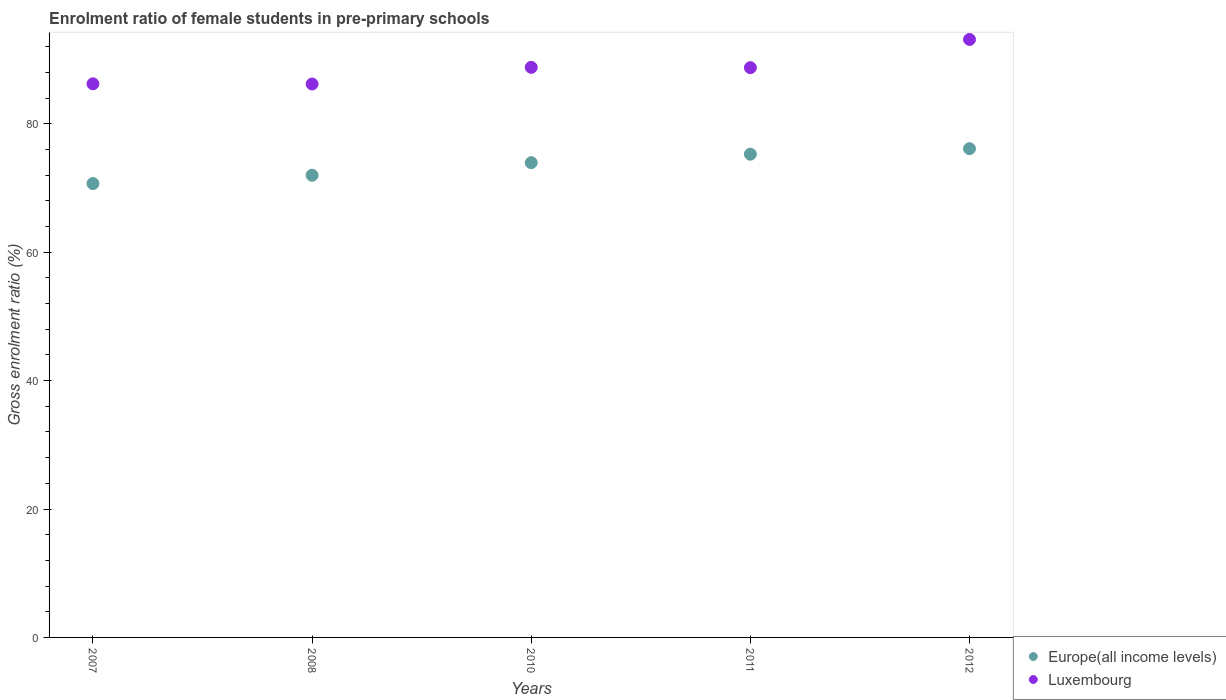How many different coloured dotlines are there?
Offer a very short reply. 2. What is the enrolment ratio of female students in pre-primary schools in Luxembourg in 2010?
Make the answer very short. 88.79. Across all years, what is the maximum enrolment ratio of female students in pre-primary schools in Europe(all income levels)?
Ensure brevity in your answer.  76.12. Across all years, what is the minimum enrolment ratio of female students in pre-primary schools in Europe(all income levels)?
Offer a terse response. 70.69. What is the total enrolment ratio of female students in pre-primary schools in Europe(all income levels) in the graph?
Offer a very short reply. 368. What is the difference between the enrolment ratio of female students in pre-primary schools in Europe(all income levels) in 2008 and that in 2012?
Your response must be concise. -4.14. What is the difference between the enrolment ratio of female students in pre-primary schools in Luxembourg in 2011 and the enrolment ratio of female students in pre-primary schools in Europe(all income levels) in 2007?
Offer a terse response. 18.05. What is the average enrolment ratio of female students in pre-primary schools in Europe(all income levels) per year?
Your answer should be very brief. 73.6. In the year 2012, what is the difference between the enrolment ratio of female students in pre-primary schools in Europe(all income levels) and enrolment ratio of female students in pre-primary schools in Luxembourg?
Your answer should be very brief. -17.01. What is the ratio of the enrolment ratio of female students in pre-primary schools in Luxembourg in 2010 to that in 2011?
Offer a very short reply. 1. Is the enrolment ratio of female students in pre-primary schools in Luxembourg in 2008 less than that in 2011?
Make the answer very short. Yes. What is the difference between the highest and the second highest enrolment ratio of female students in pre-primary schools in Europe(all income levels)?
Offer a terse response. 0.86. What is the difference between the highest and the lowest enrolment ratio of female students in pre-primary schools in Europe(all income levels)?
Keep it short and to the point. 5.43. In how many years, is the enrolment ratio of female students in pre-primary schools in Europe(all income levels) greater than the average enrolment ratio of female students in pre-primary schools in Europe(all income levels) taken over all years?
Offer a very short reply. 3. How many years are there in the graph?
Your answer should be very brief. 5. Does the graph contain any zero values?
Your answer should be very brief. No. How are the legend labels stacked?
Offer a very short reply. Vertical. What is the title of the graph?
Offer a terse response. Enrolment ratio of female students in pre-primary schools. What is the Gross enrolment ratio (%) in Europe(all income levels) in 2007?
Your response must be concise. 70.69. What is the Gross enrolment ratio (%) in Luxembourg in 2007?
Offer a terse response. 86.22. What is the Gross enrolment ratio (%) of Europe(all income levels) in 2008?
Provide a succinct answer. 71.99. What is the Gross enrolment ratio (%) of Luxembourg in 2008?
Ensure brevity in your answer.  86.2. What is the Gross enrolment ratio (%) of Europe(all income levels) in 2010?
Offer a very short reply. 73.94. What is the Gross enrolment ratio (%) in Luxembourg in 2010?
Give a very brief answer. 88.79. What is the Gross enrolment ratio (%) of Europe(all income levels) in 2011?
Keep it short and to the point. 75.27. What is the Gross enrolment ratio (%) of Luxembourg in 2011?
Provide a short and direct response. 88.74. What is the Gross enrolment ratio (%) of Europe(all income levels) in 2012?
Keep it short and to the point. 76.12. What is the Gross enrolment ratio (%) in Luxembourg in 2012?
Ensure brevity in your answer.  93.13. Across all years, what is the maximum Gross enrolment ratio (%) in Europe(all income levels)?
Your answer should be very brief. 76.12. Across all years, what is the maximum Gross enrolment ratio (%) in Luxembourg?
Provide a succinct answer. 93.13. Across all years, what is the minimum Gross enrolment ratio (%) in Europe(all income levels)?
Give a very brief answer. 70.69. Across all years, what is the minimum Gross enrolment ratio (%) in Luxembourg?
Your answer should be compact. 86.2. What is the total Gross enrolment ratio (%) in Europe(all income levels) in the graph?
Provide a succinct answer. 368. What is the total Gross enrolment ratio (%) in Luxembourg in the graph?
Offer a very short reply. 443.09. What is the difference between the Gross enrolment ratio (%) of Europe(all income levels) in 2007 and that in 2008?
Keep it short and to the point. -1.3. What is the difference between the Gross enrolment ratio (%) of Luxembourg in 2007 and that in 2008?
Your answer should be very brief. 0.03. What is the difference between the Gross enrolment ratio (%) in Europe(all income levels) in 2007 and that in 2010?
Provide a short and direct response. -3.25. What is the difference between the Gross enrolment ratio (%) of Luxembourg in 2007 and that in 2010?
Your answer should be compact. -2.57. What is the difference between the Gross enrolment ratio (%) of Europe(all income levels) in 2007 and that in 2011?
Give a very brief answer. -4.58. What is the difference between the Gross enrolment ratio (%) in Luxembourg in 2007 and that in 2011?
Make the answer very short. -2.52. What is the difference between the Gross enrolment ratio (%) of Europe(all income levels) in 2007 and that in 2012?
Your answer should be very brief. -5.43. What is the difference between the Gross enrolment ratio (%) of Luxembourg in 2007 and that in 2012?
Keep it short and to the point. -6.91. What is the difference between the Gross enrolment ratio (%) in Europe(all income levels) in 2008 and that in 2010?
Ensure brevity in your answer.  -1.96. What is the difference between the Gross enrolment ratio (%) in Luxembourg in 2008 and that in 2010?
Offer a terse response. -2.6. What is the difference between the Gross enrolment ratio (%) of Europe(all income levels) in 2008 and that in 2011?
Ensure brevity in your answer.  -3.28. What is the difference between the Gross enrolment ratio (%) in Luxembourg in 2008 and that in 2011?
Provide a succinct answer. -2.55. What is the difference between the Gross enrolment ratio (%) in Europe(all income levels) in 2008 and that in 2012?
Ensure brevity in your answer.  -4.14. What is the difference between the Gross enrolment ratio (%) in Luxembourg in 2008 and that in 2012?
Offer a very short reply. -6.94. What is the difference between the Gross enrolment ratio (%) in Europe(all income levels) in 2010 and that in 2011?
Provide a short and direct response. -1.32. What is the difference between the Gross enrolment ratio (%) in Luxembourg in 2010 and that in 2011?
Give a very brief answer. 0.05. What is the difference between the Gross enrolment ratio (%) in Europe(all income levels) in 2010 and that in 2012?
Provide a succinct answer. -2.18. What is the difference between the Gross enrolment ratio (%) in Luxembourg in 2010 and that in 2012?
Your answer should be very brief. -4.34. What is the difference between the Gross enrolment ratio (%) of Europe(all income levels) in 2011 and that in 2012?
Provide a succinct answer. -0.86. What is the difference between the Gross enrolment ratio (%) of Luxembourg in 2011 and that in 2012?
Offer a very short reply. -4.39. What is the difference between the Gross enrolment ratio (%) of Europe(all income levels) in 2007 and the Gross enrolment ratio (%) of Luxembourg in 2008?
Offer a terse response. -15.51. What is the difference between the Gross enrolment ratio (%) of Europe(all income levels) in 2007 and the Gross enrolment ratio (%) of Luxembourg in 2010?
Make the answer very short. -18.1. What is the difference between the Gross enrolment ratio (%) of Europe(all income levels) in 2007 and the Gross enrolment ratio (%) of Luxembourg in 2011?
Keep it short and to the point. -18.05. What is the difference between the Gross enrolment ratio (%) in Europe(all income levels) in 2007 and the Gross enrolment ratio (%) in Luxembourg in 2012?
Your answer should be compact. -22.45. What is the difference between the Gross enrolment ratio (%) of Europe(all income levels) in 2008 and the Gross enrolment ratio (%) of Luxembourg in 2010?
Provide a short and direct response. -16.81. What is the difference between the Gross enrolment ratio (%) in Europe(all income levels) in 2008 and the Gross enrolment ratio (%) in Luxembourg in 2011?
Keep it short and to the point. -16.76. What is the difference between the Gross enrolment ratio (%) in Europe(all income levels) in 2008 and the Gross enrolment ratio (%) in Luxembourg in 2012?
Offer a terse response. -21.15. What is the difference between the Gross enrolment ratio (%) in Europe(all income levels) in 2010 and the Gross enrolment ratio (%) in Luxembourg in 2011?
Offer a terse response. -14.8. What is the difference between the Gross enrolment ratio (%) of Europe(all income levels) in 2010 and the Gross enrolment ratio (%) of Luxembourg in 2012?
Your answer should be very brief. -19.19. What is the difference between the Gross enrolment ratio (%) of Europe(all income levels) in 2011 and the Gross enrolment ratio (%) of Luxembourg in 2012?
Your answer should be very brief. -17.87. What is the average Gross enrolment ratio (%) of Europe(all income levels) per year?
Provide a short and direct response. 73.6. What is the average Gross enrolment ratio (%) of Luxembourg per year?
Give a very brief answer. 88.62. In the year 2007, what is the difference between the Gross enrolment ratio (%) in Europe(all income levels) and Gross enrolment ratio (%) in Luxembourg?
Provide a succinct answer. -15.54. In the year 2008, what is the difference between the Gross enrolment ratio (%) in Europe(all income levels) and Gross enrolment ratio (%) in Luxembourg?
Offer a very short reply. -14.21. In the year 2010, what is the difference between the Gross enrolment ratio (%) of Europe(all income levels) and Gross enrolment ratio (%) of Luxembourg?
Give a very brief answer. -14.85. In the year 2011, what is the difference between the Gross enrolment ratio (%) of Europe(all income levels) and Gross enrolment ratio (%) of Luxembourg?
Offer a very short reply. -13.48. In the year 2012, what is the difference between the Gross enrolment ratio (%) of Europe(all income levels) and Gross enrolment ratio (%) of Luxembourg?
Keep it short and to the point. -17.01. What is the ratio of the Gross enrolment ratio (%) of Luxembourg in 2007 to that in 2008?
Provide a short and direct response. 1. What is the ratio of the Gross enrolment ratio (%) in Europe(all income levels) in 2007 to that in 2010?
Give a very brief answer. 0.96. What is the ratio of the Gross enrolment ratio (%) of Luxembourg in 2007 to that in 2010?
Offer a very short reply. 0.97. What is the ratio of the Gross enrolment ratio (%) of Europe(all income levels) in 2007 to that in 2011?
Your answer should be compact. 0.94. What is the ratio of the Gross enrolment ratio (%) in Luxembourg in 2007 to that in 2011?
Keep it short and to the point. 0.97. What is the ratio of the Gross enrolment ratio (%) in Luxembourg in 2007 to that in 2012?
Give a very brief answer. 0.93. What is the ratio of the Gross enrolment ratio (%) in Europe(all income levels) in 2008 to that in 2010?
Offer a terse response. 0.97. What is the ratio of the Gross enrolment ratio (%) of Luxembourg in 2008 to that in 2010?
Offer a very short reply. 0.97. What is the ratio of the Gross enrolment ratio (%) of Europe(all income levels) in 2008 to that in 2011?
Your answer should be compact. 0.96. What is the ratio of the Gross enrolment ratio (%) of Luxembourg in 2008 to that in 2011?
Keep it short and to the point. 0.97. What is the ratio of the Gross enrolment ratio (%) of Europe(all income levels) in 2008 to that in 2012?
Provide a succinct answer. 0.95. What is the ratio of the Gross enrolment ratio (%) in Luxembourg in 2008 to that in 2012?
Provide a short and direct response. 0.93. What is the ratio of the Gross enrolment ratio (%) in Europe(all income levels) in 2010 to that in 2011?
Your answer should be compact. 0.98. What is the ratio of the Gross enrolment ratio (%) in Europe(all income levels) in 2010 to that in 2012?
Your response must be concise. 0.97. What is the ratio of the Gross enrolment ratio (%) in Luxembourg in 2010 to that in 2012?
Give a very brief answer. 0.95. What is the ratio of the Gross enrolment ratio (%) of Europe(all income levels) in 2011 to that in 2012?
Make the answer very short. 0.99. What is the ratio of the Gross enrolment ratio (%) of Luxembourg in 2011 to that in 2012?
Offer a terse response. 0.95. What is the difference between the highest and the second highest Gross enrolment ratio (%) in Europe(all income levels)?
Offer a very short reply. 0.86. What is the difference between the highest and the second highest Gross enrolment ratio (%) of Luxembourg?
Make the answer very short. 4.34. What is the difference between the highest and the lowest Gross enrolment ratio (%) in Europe(all income levels)?
Offer a terse response. 5.43. What is the difference between the highest and the lowest Gross enrolment ratio (%) in Luxembourg?
Make the answer very short. 6.94. 